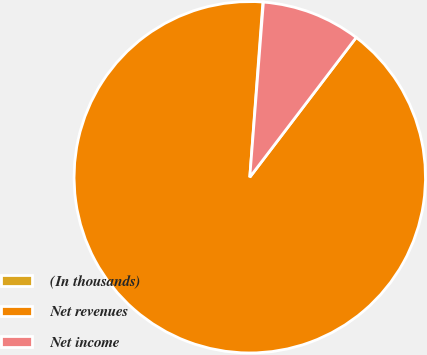Convert chart. <chart><loc_0><loc_0><loc_500><loc_500><pie_chart><fcel>(In thousands)<fcel>Net revenues<fcel>Net income<nl><fcel>0.05%<fcel>90.83%<fcel>9.12%<nl></chart> 